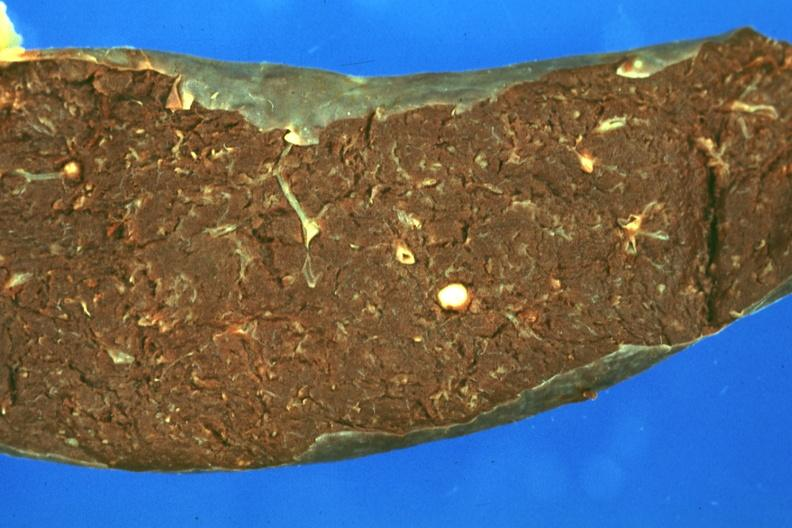s spleen present?
Answer the question using a single word or phrase. Yes 